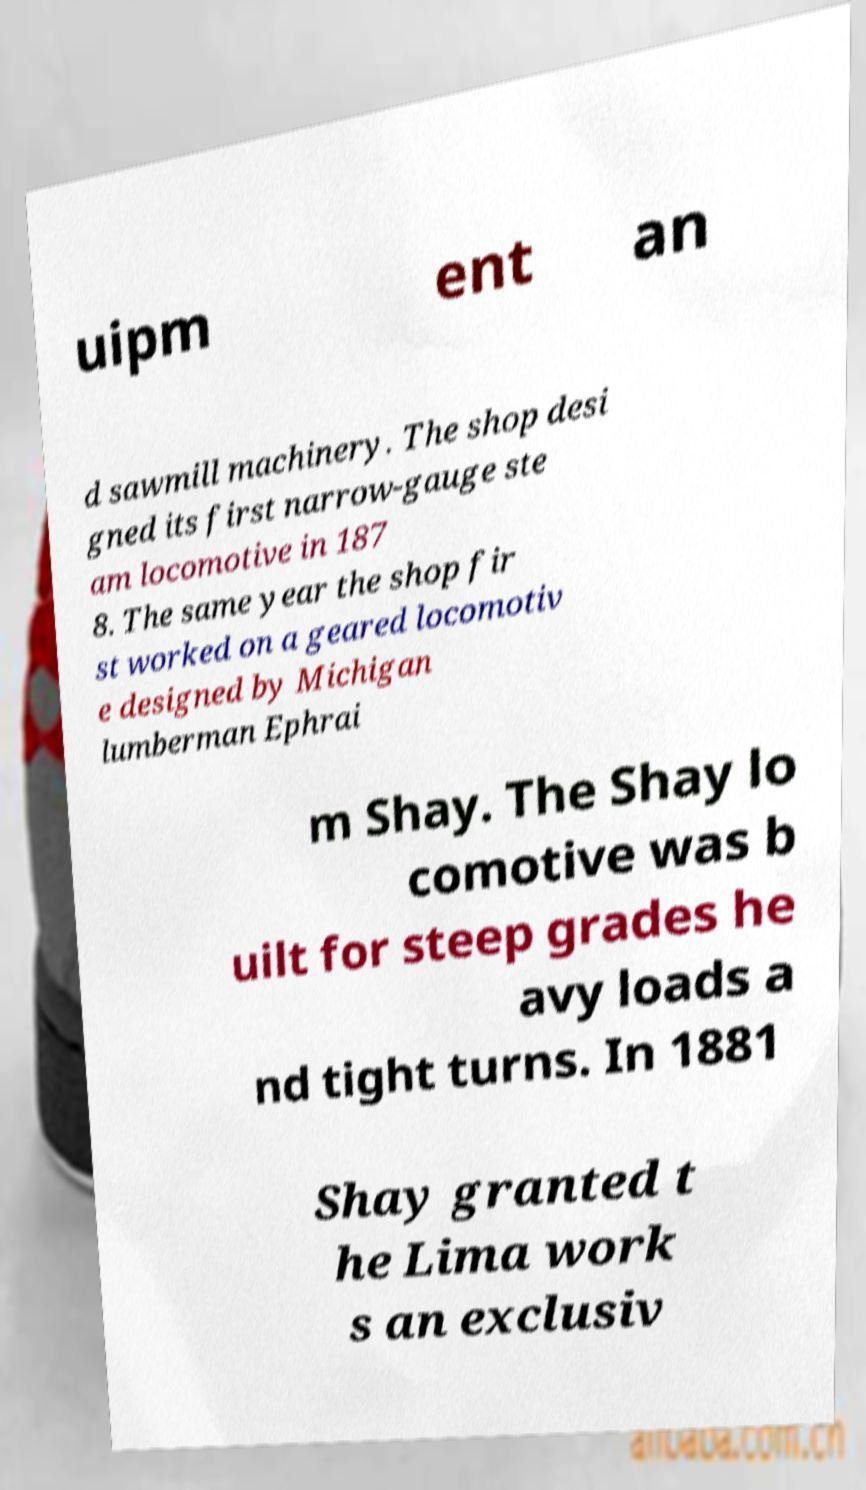I need the written content from this picture converted into text. Can you do that? uipm ent an d sawmill machinery. The shop desi gned its first narrow-gauge ste am locomotive in 187 8. The same year the shop fir st worked on a geared locomotiv e designed by Michigan lumberman Ephrai m Shay. The Shay lo comotive was b uilt for steep grades he avy loads a nd tight turns. In 1881 Shay granted t he Lima work s an exclusiv 